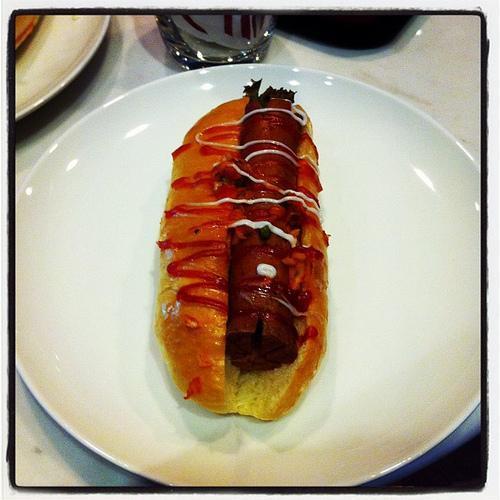How many sausages are on the plate?
Give a very brief answer. 1. 